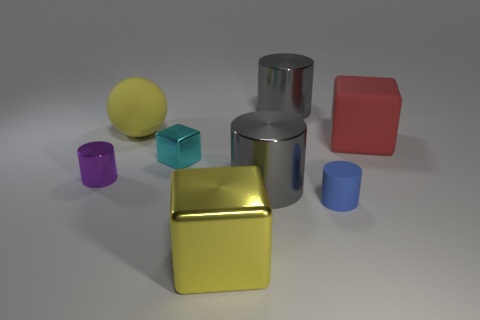How many objects are big yellow objects or gray cylinders that are in front of the red thing?
Your answer should be very brief. 3. Are there any cyan matte things of the same shape as the yellow matte object?
Give a very brief answer. No. What is the size of the gray thing that is in front of the gray object that is behind the tiny cyan object?
Make the answer very short. Large. Is the color of the small shiny cube the same as the tiny metallic cylinder?
Ensure brevity in your answer.  No. What number of metal things are yellow spheres or cylinders?
Provide a succinct answer. 3. What number of tiny green metal cylinders are there?
Offer a terse response. 0. Are the cylinder that is behind the small shiny cube and the gray cylinder in front of the big rubber cube made of the same material?
Ensure brevity in your answer.  Yes. There is a small metallic object that is the same shape as the red matte object; what is its color?
Keep it short and to the point. Cyan. What material is the large gray cylinder left of the metallic thing that is behind the cyan block made of?
Provide a short and direct response. Metal. There is a small metallic object that is in front of the cyan shiny block; is its shape the same as the yellow thing behind the matte cube?
Your answer should be very brief. No. 